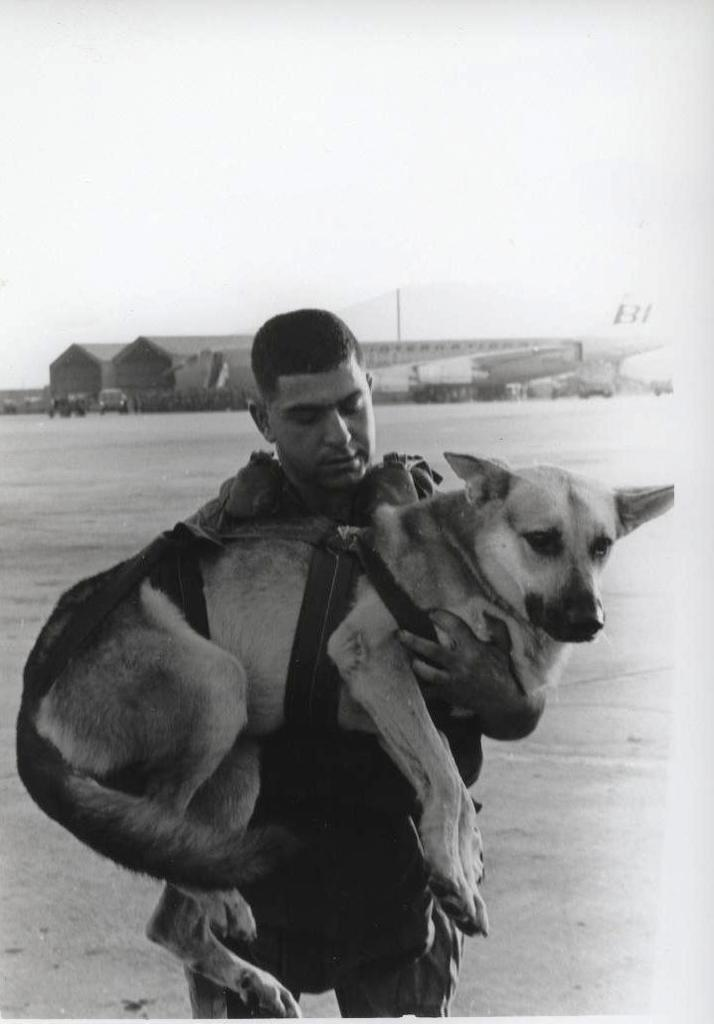Who is present in the image? There is a man in the image. What is the man holding in the image? The man is holding a dog. What can be seen in the background of the image? There are vehicles visible in the background of the image. How many babies are present in the image? There are no babies present in the image; it features a man holding a dog. What type of fiction is the man reading to the dog in the image? There is no fiction or reading activity depicted in the image; the man is simply holding a dog. 